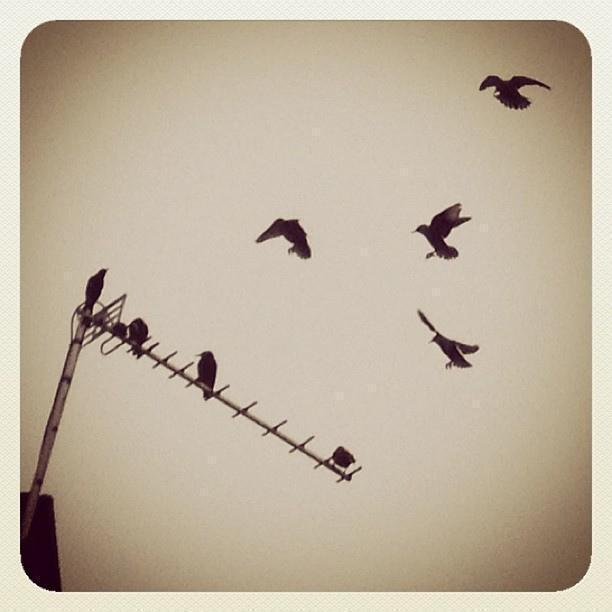Why do the birds seek high up places?
Choose the right answer from the provided options to respond to the question.
Options: Like flying, safety, see more, exercise. Safety. 